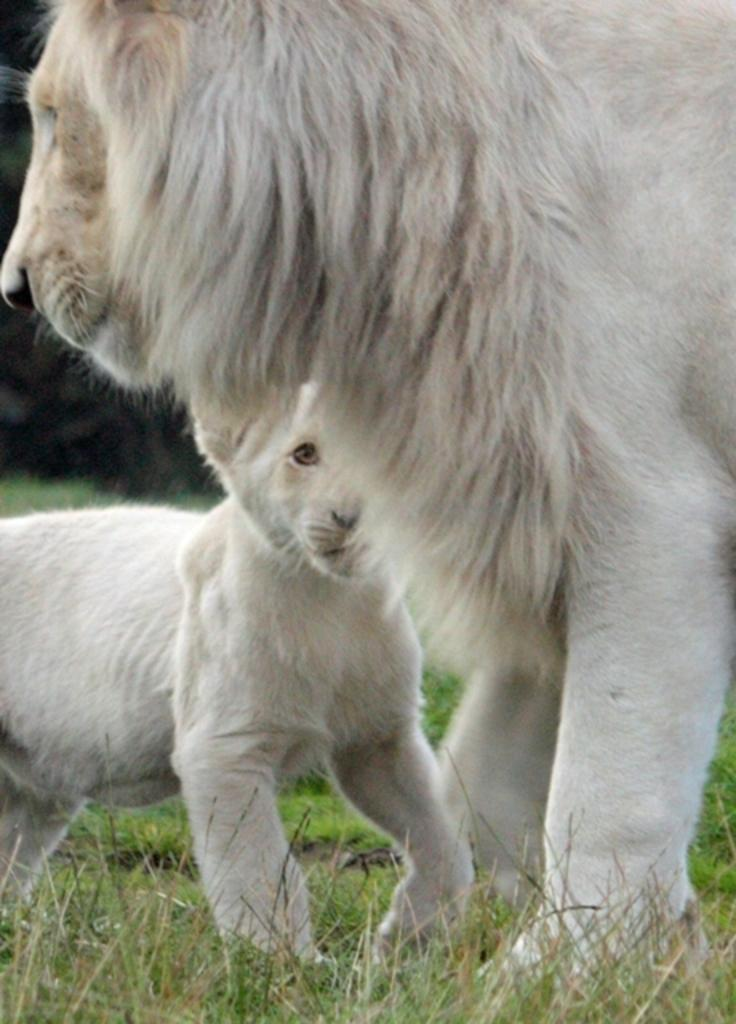What type of animal is in the image? There is a white lion in the image. Is there a baby animal in the image? Yes, there is a white cub in the image. What is the surface on which the lion and cub are standing? Both the lion and the cub are on the grass. What color is the pail that the lion is holding in the image? There is no pail present in the image; the lion and cub are on the grass. 